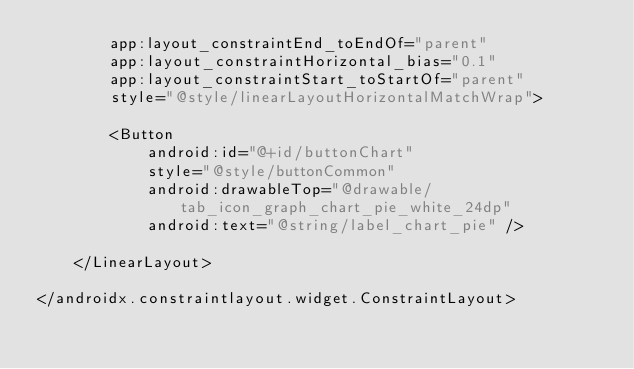Convert code to text. <code><loc_0><loc_0><loc_500><loc_500><_XML_>        app:layout_constraintEnd_toEndOf="parent"
        app:layout_constraintHorizontal_bias="0.1"
        app:layout_constraintStart_toStartOf="parent"
        style="@style/linearLayoutHorizontalMatchWrap">

        <Button
            android:id="@+id/buttonChart"
            style="@style/buttonCommon"
            android:drawableTop="@drawable/tab_icon_graph_chart_pie_white_24dp"
            android:text="@string/label_chart_pie" />

    </LinearLayout>

</androidx.constraintlayout.widget.ConstraintLayout></code> 